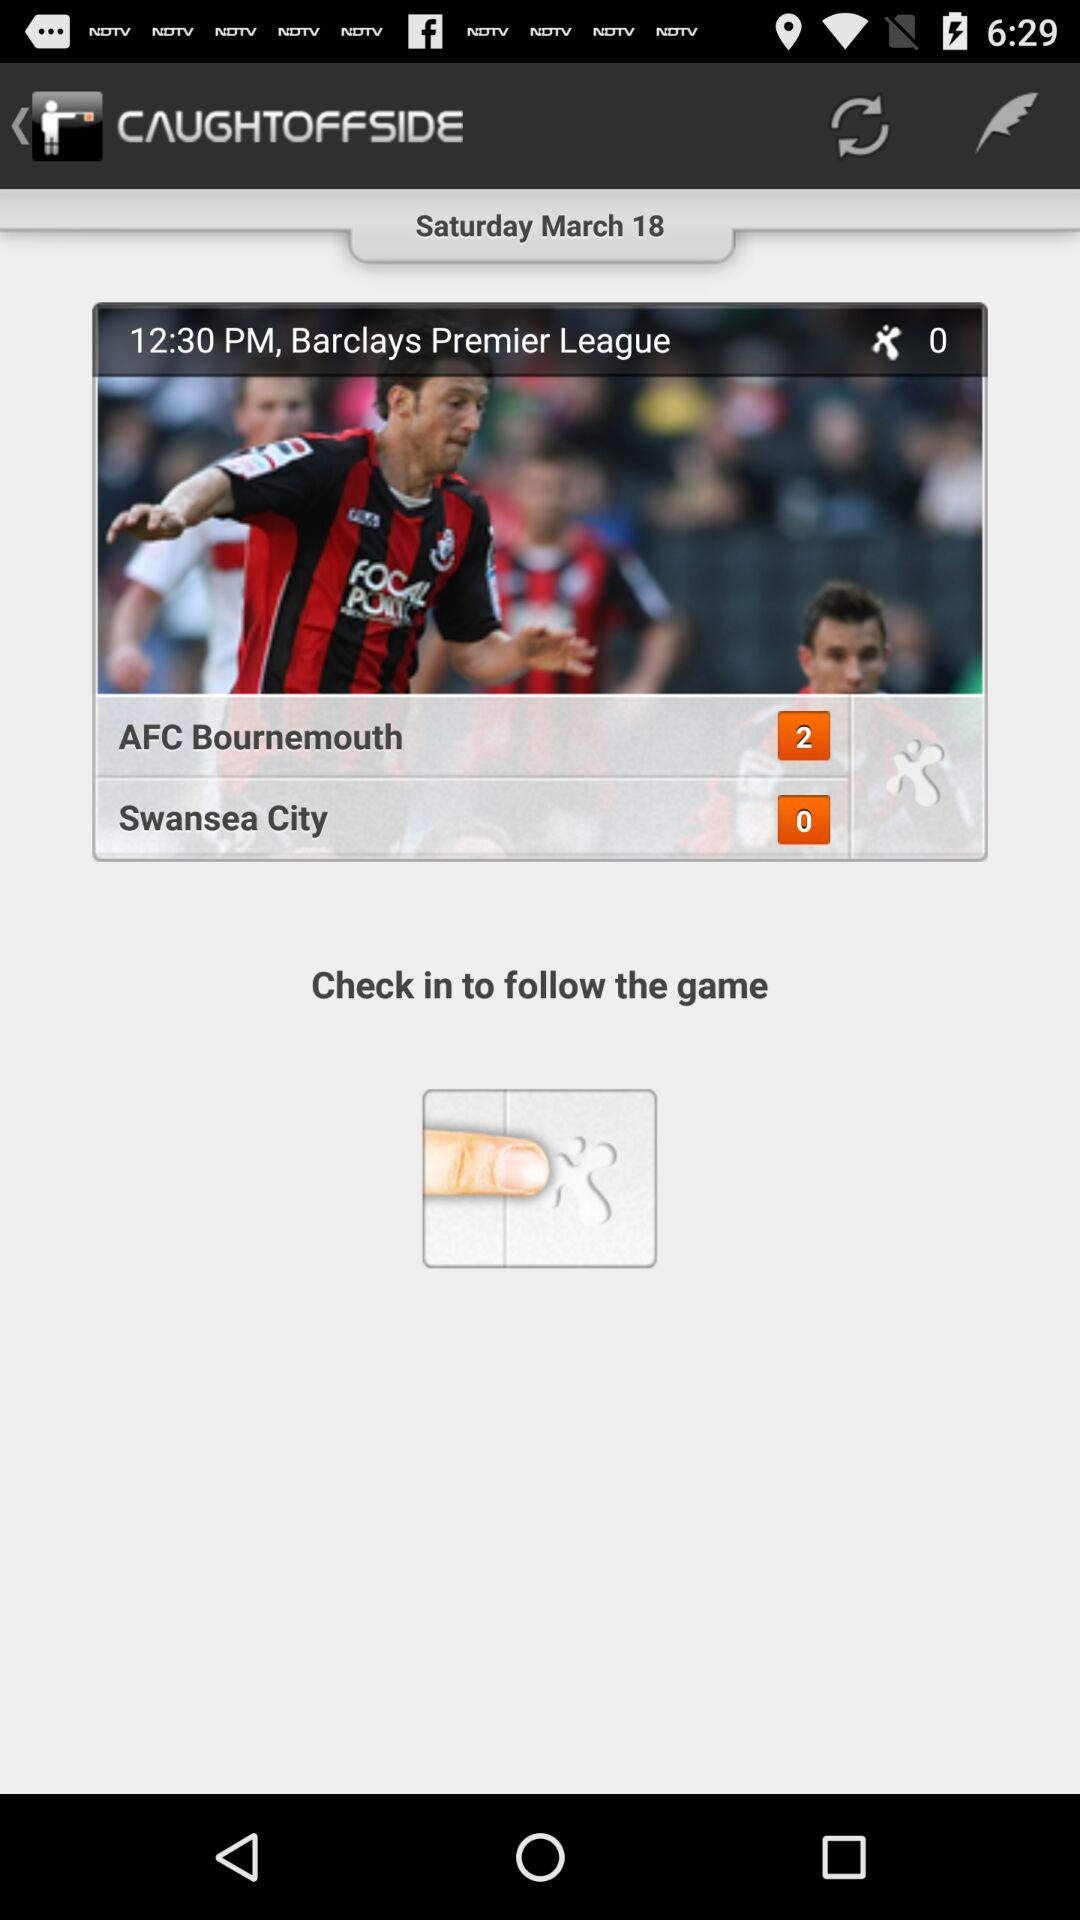What is the score of "Swansea City"? The score of "Swansea City" is 0. 